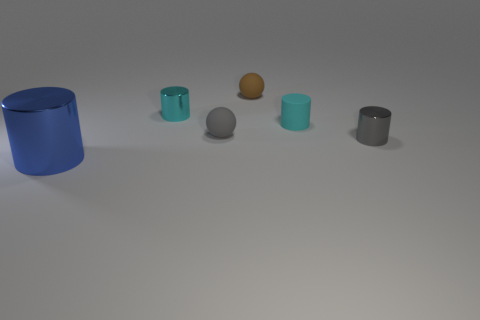What might be the purpose of this collection of objects? This collection of objects, with its varied shapes and materials, could serve an educational or demonstrative purpose. It seems designed to illustrate various properties such as color, material, reflectivity, and size, which might make it useful for a graphical rendering test or a study in physical properties and light interaction. 